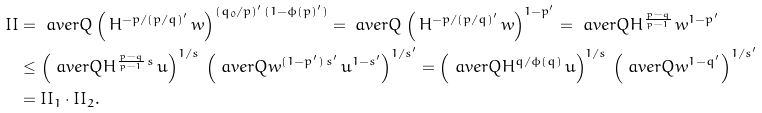<formula> <loc_0><loc_0><loc_500><loc_500>I I & = \ a v e r { Q } \left ( \, H ^ { - p / ( p / q ) ^ { \prime } } \, w \right ) ^ { ( q _ { 0 } / p ) ^ { \prime } \, ( 1 - \phi ( p ) ^ { \prime } ) } = \ a v e r { Q } \left ( \, H ^ { - p / ( p / q ) ^ { \prime } } \, w \right ) ^ { 1 - p ^ { \prime } } = \ a v e r { Q } H ^ { \frac { p - q } { p - 1 } } \, w ^ { 1 - p ^ { \prime } } \\ & \leq \left ( \ a v e r { Q } H ^ { \frac { p - q } { p - 1 } \, s } \, u \right ) ^ { 1 / s } \, \left ( \ a v e r { Q } w ^ { ( 1 - p ^ { \prime } ) \, s ^ { \prime } } \, u ^ { 1 - s ^ { \prime } } \right ) ^ { 1 / s ^ { \prime } } = \left ( \ a v e r { Q } H ^ { q / \phi ( q ) } \, u \right ) ^ { 1 / s } \, \left ( \ a v e r { Q } w ^ { 1 - q ^ { \prime } } \right ) ^ { 1 / s ^ { \prime } } \\ & = I I _ { 1 } \cdot I I _ { 2 } .</formula> 